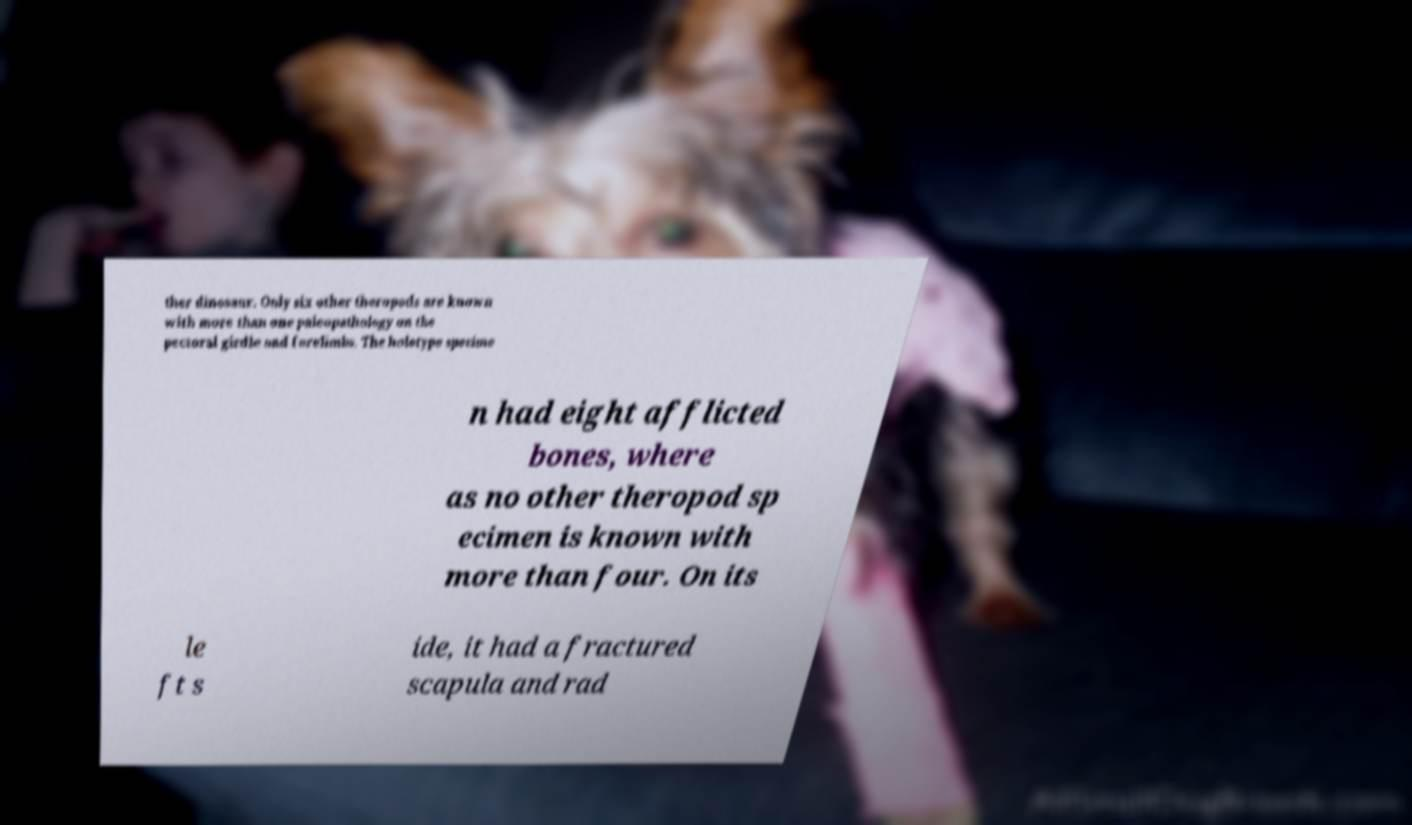Please identify and transcribe the text found in this image. ther dinosaur. Only six other theropods are known with more than one paleopathology on the pectoral girdle and forelimbs. The holotype specime n had eight afflicted bones, where as no other theropod sp ecimen is known with more than four. On its le ft s ide, it had a fractured scapula and rad 